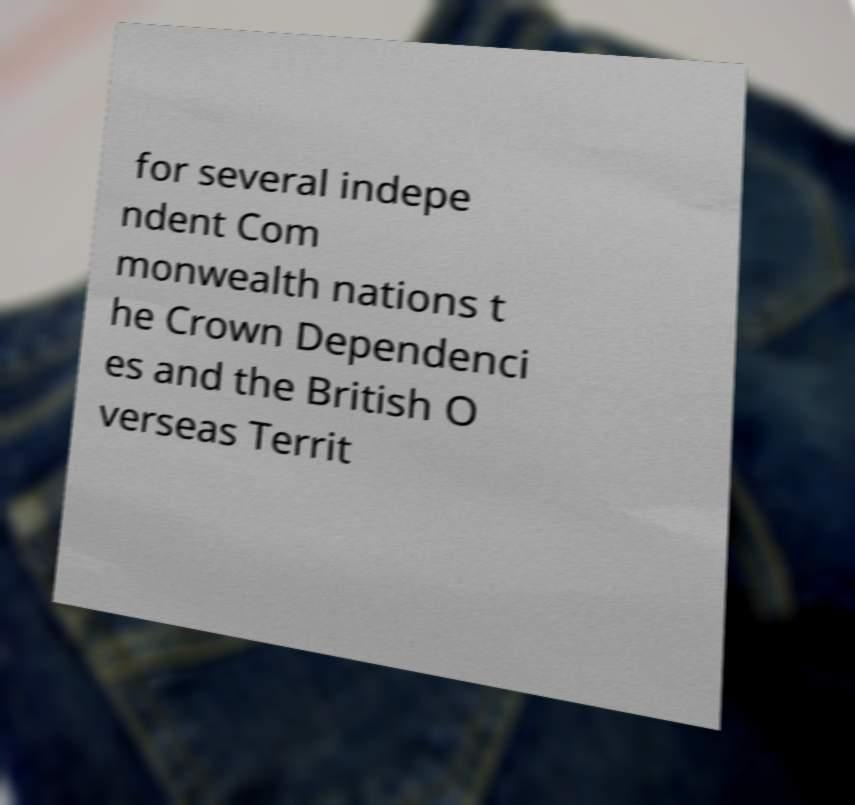For documentation purposes, I need the text within this image transcribed. Could you provide that? for several indepe ndent Com monwealth nations t he Crown Dependenci es and the British O verseas Territ 